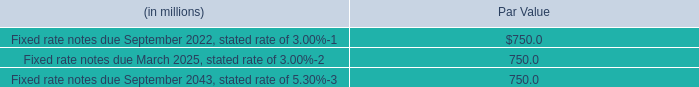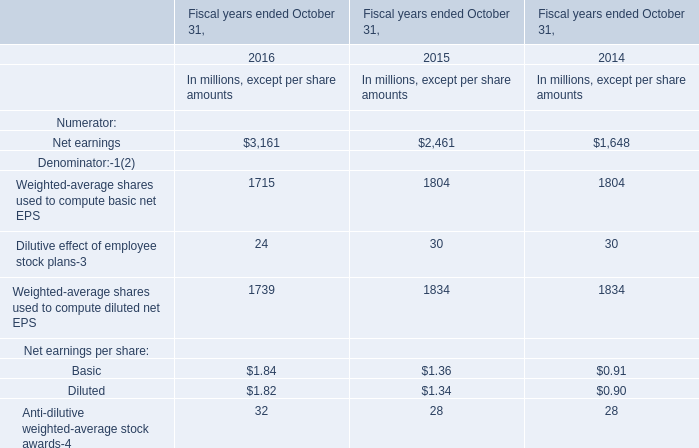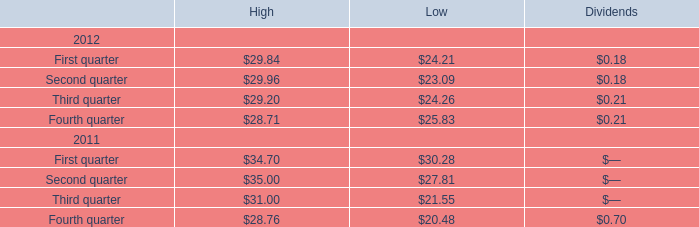What is the sum of the Corporate bonds in the years where Corporate bonds is greater than 1? 
Computations: (29.96 + 35)
Answer: 64.96. 